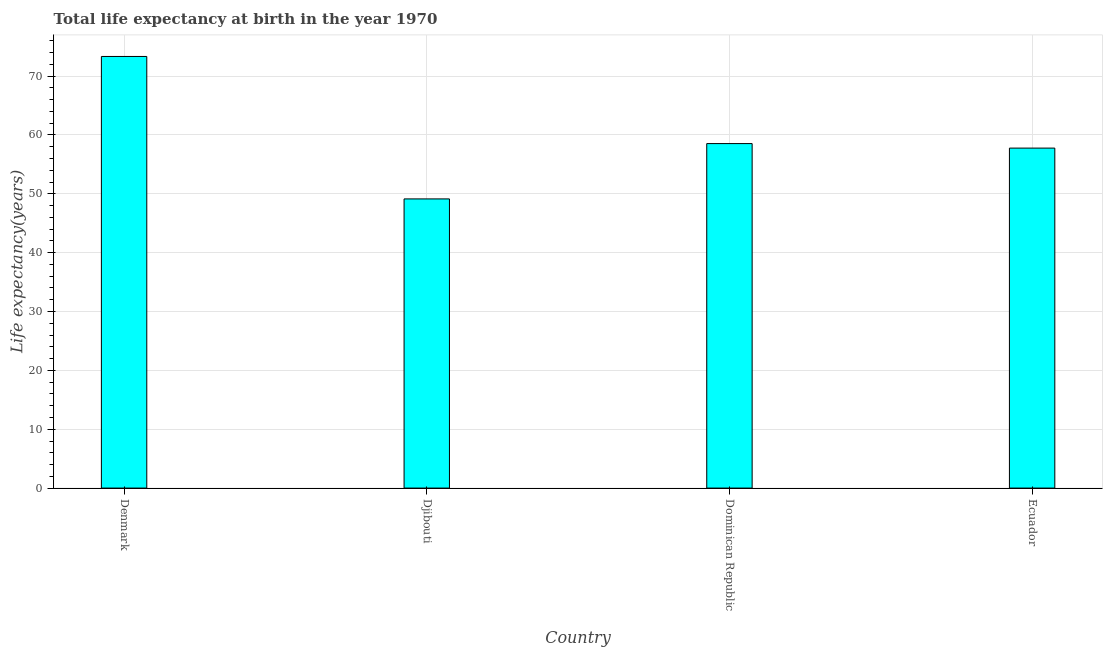What is the title of the graph?
Your answer should be very brief. Total life expectancy at birth in the year 1970. What is the label or title of the Y-axis?
Offer a very short reply. Life expectancy(years). What is the life expectancy at birth in Denmark?
Provide a short and direct response. 73.34. Across all countries, what is the maximum life expectancy at birth?
Offer a very short reply. 73.34. Across all countries, what is the minimum life expectancy at birth?
Provide a short and direct response. 49.14. In which country was the life expectancy at birth minimum?
Make the answer very short. Djibouti. What is the sum of the life expectancy at birth?
Your answer should be compact. 238.79. What is the difference between the life expectancy at birth in Denmark and Ecuador?
Ensure brevity in your answer.  15.57. What is the average life expectancy at birth per country?
Provide a succinct answer. 59.7. What is the median life expectancy at birth?
Give a very brief answer. 58.15. In how many countries, is the life expectancy at birth greater than 52 years?
Your answer should be very brief. 3. What is the ratio of the life expectancy at birth in Djibouti to that in Dominican Republic?
Offer a very short reply. 0.84. What is the difference between the highest and the second highest life expectancy at birth?
Your answer should be very brief. 14.8. Is the sum of the life expectancy at birth in Denmark and Dominican Republic greater than the maximum life expectancy at birth across all countries?
Your answer should be very brief. Yes. What is the difference between the highest and the lowest life expectancy at birth?
Ensure brevity in your answer.  24.21. In how many countries, is the life expectancy at birth greater than the average life expectancy at birth taken over all countries?
Offer a very short reply. 1. How many bars are there?
Your answer should be very brief. 4. Are the values on the major ticks of Y-axis written in scientific E-notation?
Keep it short and to the point. No. What is the Life expectancy(years) in Denmark?
Your answer should be very brief. 73.34. What is the Life expectancy(years) of Djibouti?
Your answer should be very brief. 49.14. What is the Life expectancy(years) in Dominican Republic?
Provide a succinct answer. 58.54. What is the Life expectancy(years) in Ecuador?
Give a very brief answer. 57.77. What is the difference between the Life expectancy(years) in Denmark and Djibouti?
Provide a short and direct response. 24.21. What is the difference between the Life expectancy(years) in Denmark and Dominican Republic?
Your answer should be compact. 14.8. What is the difference between the Life expectancy(years) in Denmark and Ecuador?
Provide a short and direct response. 15.57. What is the difference between the Life expectancy(years) in Djibouti and Dominican Republic?
Offer a very short reply. -9.4. What is the difference between the Life expectancy(years) in Djibouti and Ecuador?
Your answer should be very brief. -8.63. What is the difference between the Life expectancy(years) in Dominican Republic and Ecuador?
Your answer should be very brief. 0.77. What is the ratio of the Life expectancy(years) in Denmark to that in Djibouti?
Make the answer very short. 1.49. What is the ratio of the Life expectancy(years) in Denmark to that in Dominican Republic?
Provide a succinct answer. 1.25. What is the ratio of the Life expectancy(years) in Denmark to that in Ecuador?
Provide a succinct answer. 1.27. What is the ratio of the Life expectancy(years) in Djibouti to that in Dominican Republic?
Keep it short and to the point. 0.84. What is the ratio of the Life expectancy(years) in Djibouti to that in Ecuador?
Provide a short and direct response. 0.85. What is the ratio of the Life expectancy(years) in Dominican Republic to that in Ecuador?
Ensure brevity in your answer.  1.01. 